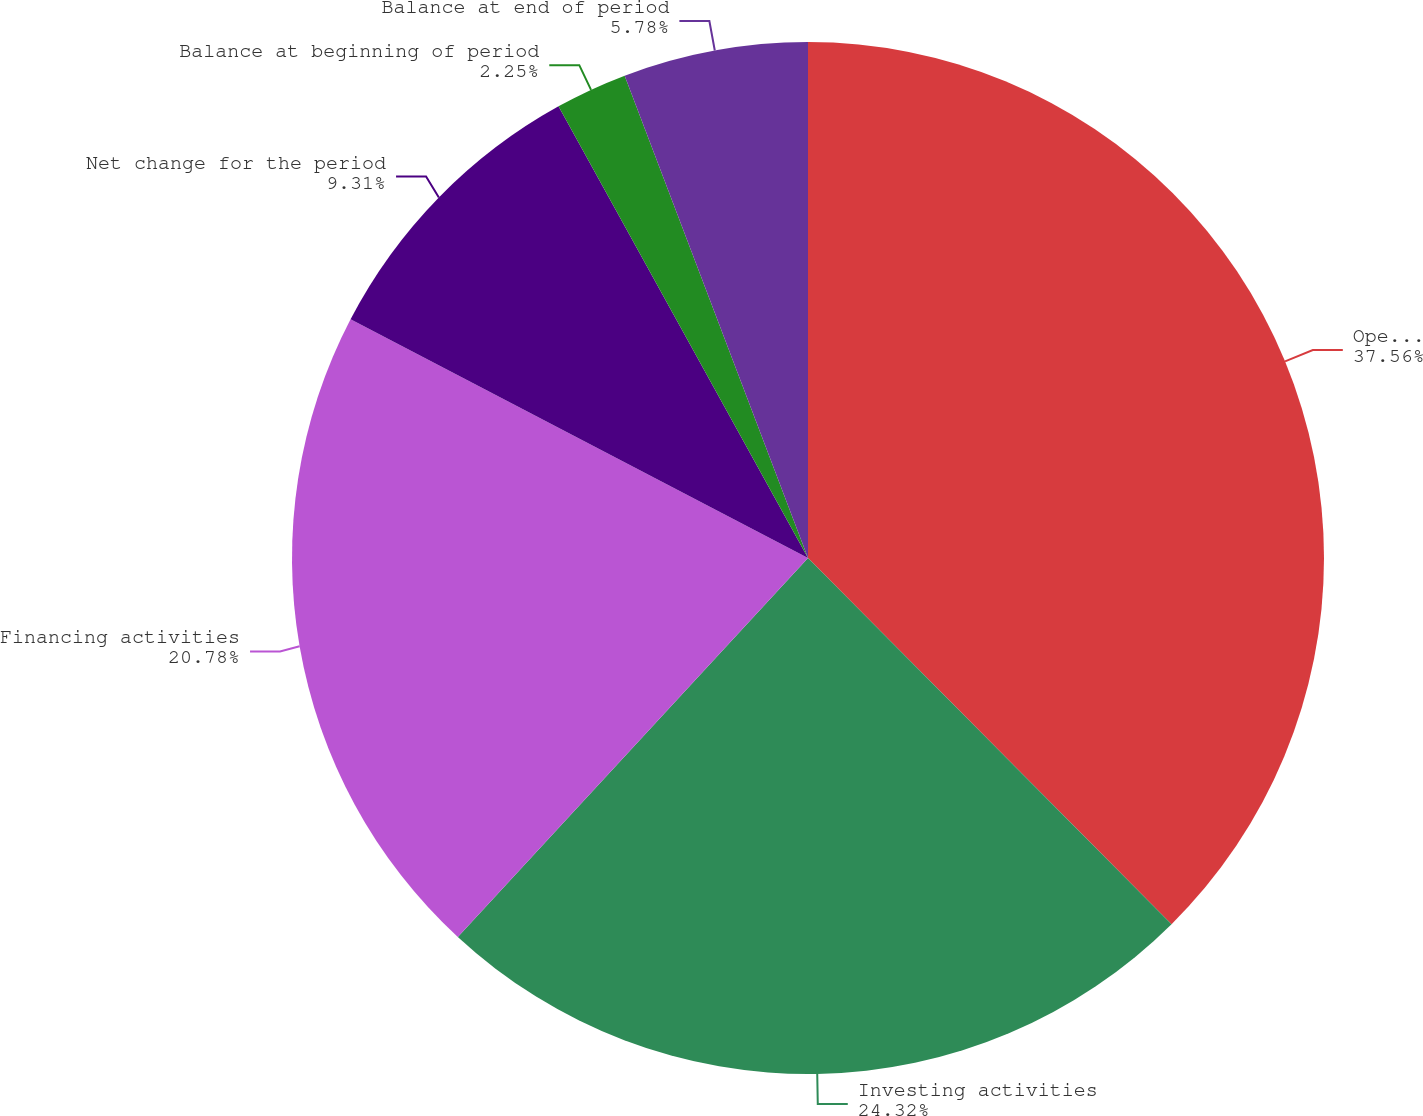<chart> <loc_0><loc_0><loc_500><loc_500><pie_chart><fcel>Operating activities<fcel>Investing activities<fcel>Financing activities<fcel>Net change for the period<fcel>Balance at beginning of period<fcel>Balance at end of period<nl><fcel>37.55%<fcel>24.31%<fcel>20.78%<fcel>9.31%<fcel>2.25%<fcel>5.78%<nl></chart> 